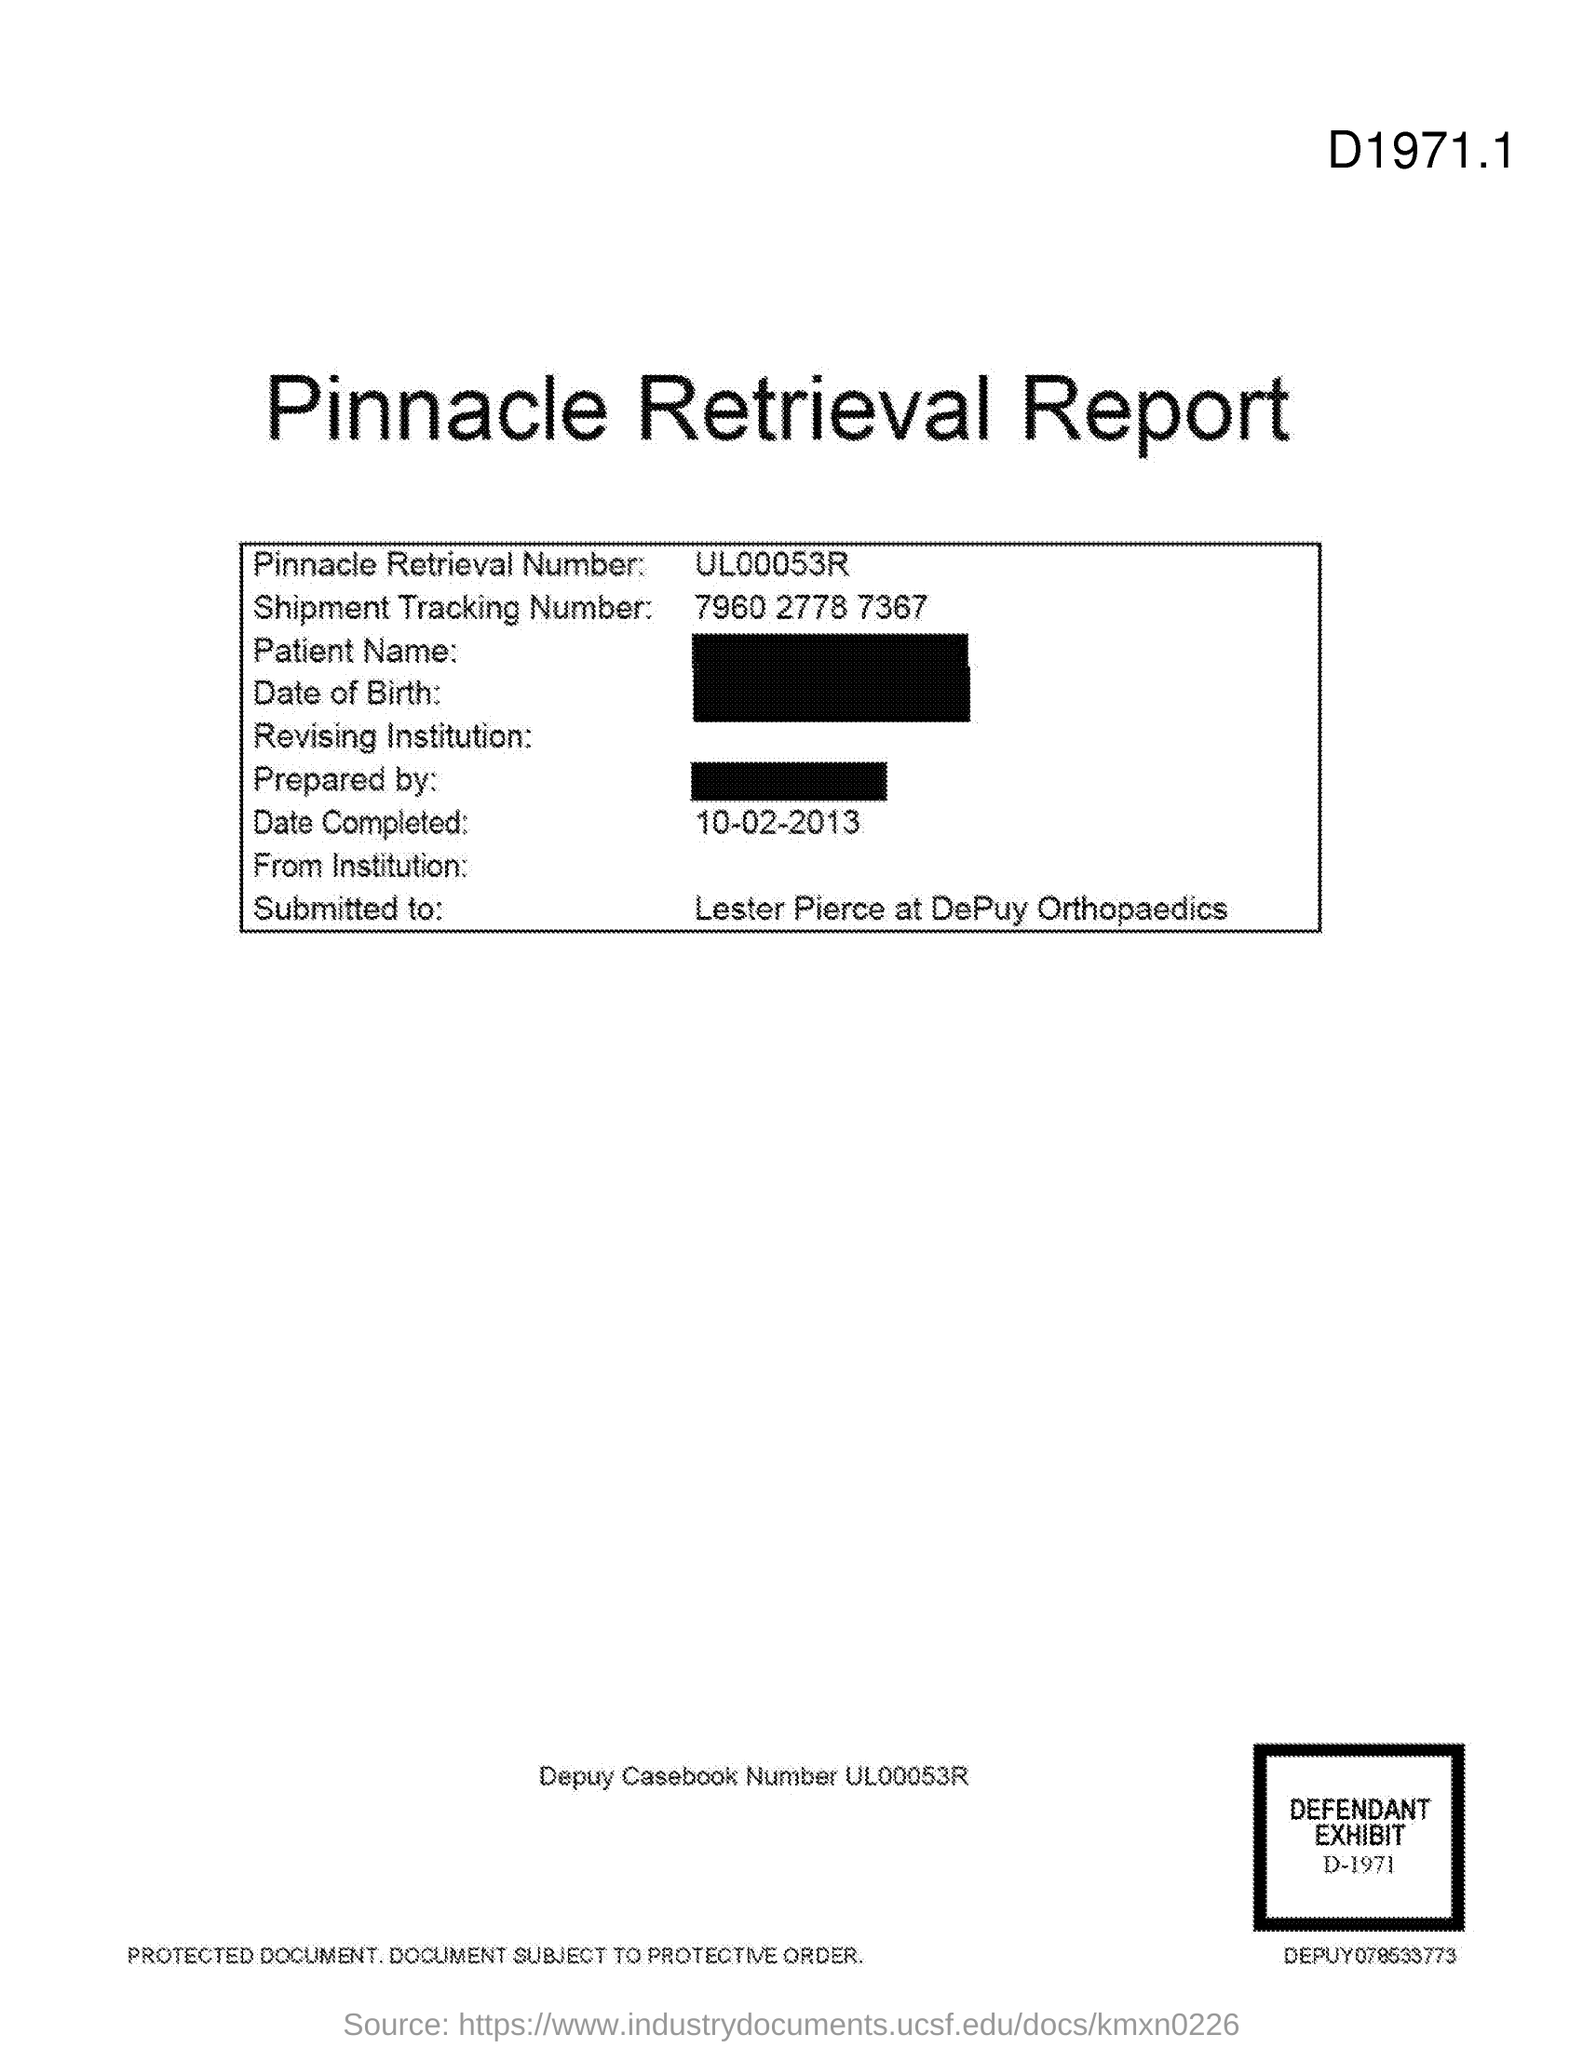What is the title of the document?
Keep it short and to the point. Pinnacle Retrieval Report. What is the Pinnacle Retrieval Number?
Provide a short and direct response. UL00053R. What is the Shipment Tracking Number?
Your answer should be compact. 7960 2778 7367. 